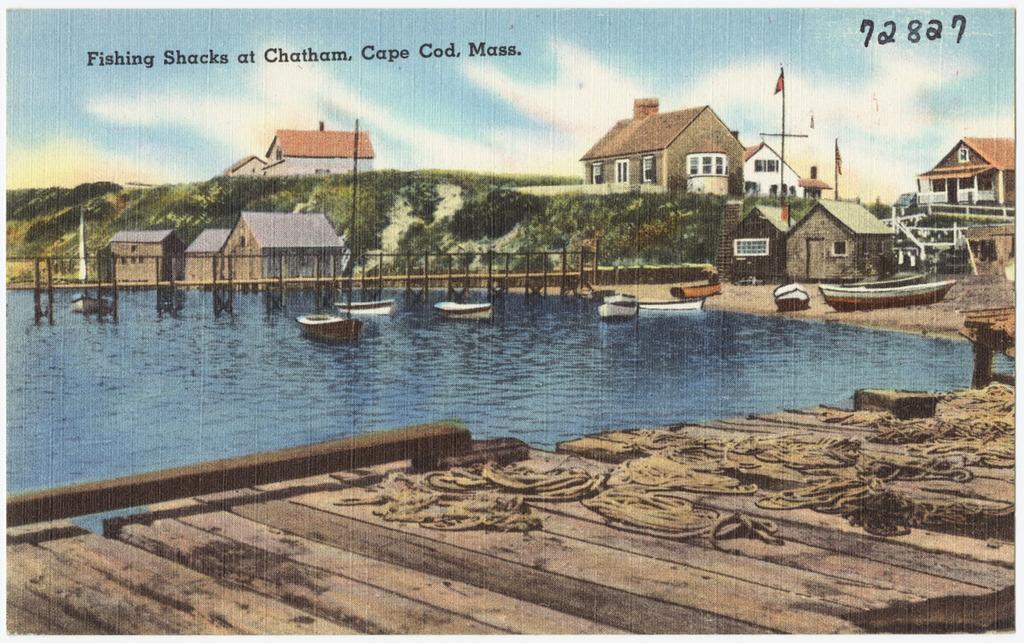In one or two sentences, can you explain what this image depicts? This image is a depiction, in this image there is a wooden surface and a water surface on that there are boats and a bridge, in the background there are houses, mountain and the sky, at the top there is text. 